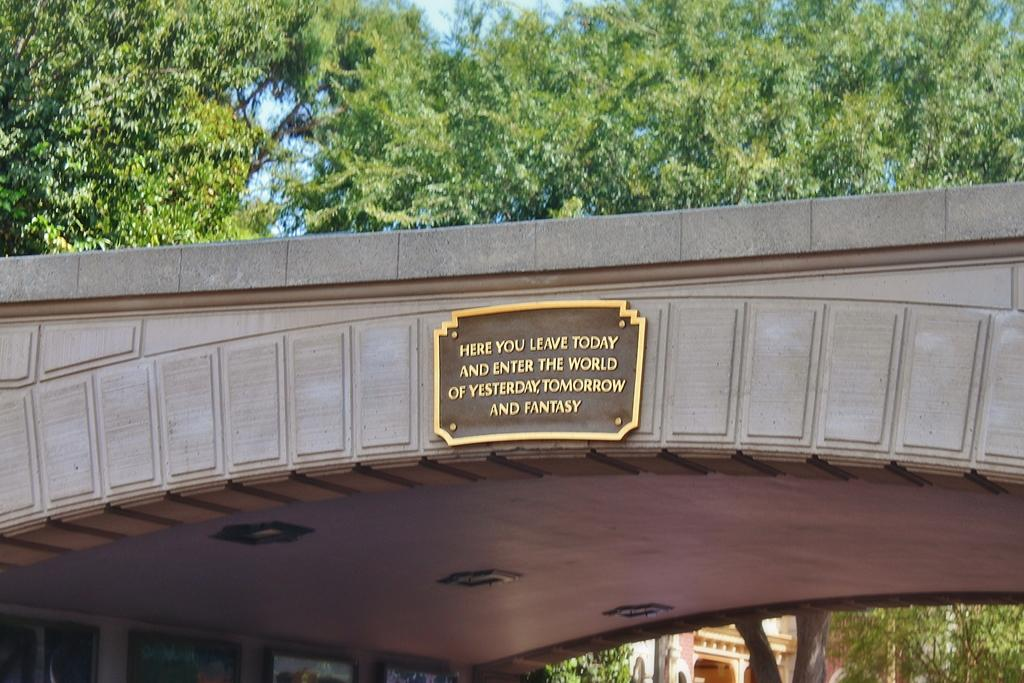<image>
Summarize the visual content of the image. The plaque on the bridge says "Here you leave today and enter the world of yesterday, tomorrow, and fantasy". 